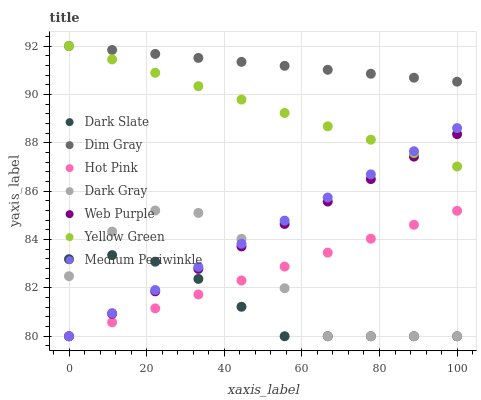Does Dark Slate have the minimum area under the curve?
Answer yes or no. Yes. Does Dim Gray have the maximum area under the curve?
Answer yes or no. Yes. Does Yellow Green have the minimum area under the curve?
Answer yes or no. No. Does Yellow Green have the maximum area under the curve?
Answer yes or no. No. Is Hot Pink the smoothest?
Answer yes or no. Yes. Is Dark Gray the roughest?
Answer yes or no. Yes. Is Yellow Green the smoothest?
Answer yes or no. No. Is Yellow Green the roughest?
Answer yes or no. No. Does Hot Pink have the lowest value?
Answer yes or no. Yes. Does Yellow Green have the lowest value?
Answer yes or no. No. Does Yellow Green have the highest value?
Answer yes or no. Yes. Does Hot Pink have the highest value?
Answer yes or no. No. Is Web Purple less than Dim Gray?
Answer yes or no. Yes. Is Dim Gray greater than Dark Gray?
Answer yes or no. Yes. Does Web Purple intersect Dark Gray?
Answer yes or no. Yes. Is Web Purple less than Dark Gray?
Answer yes or no. No. Is Web Purple greater than Dark Gray?
Answer yes or no. No. Does Web Purple intersect Dim Gray?
Answer yes or no. No. 